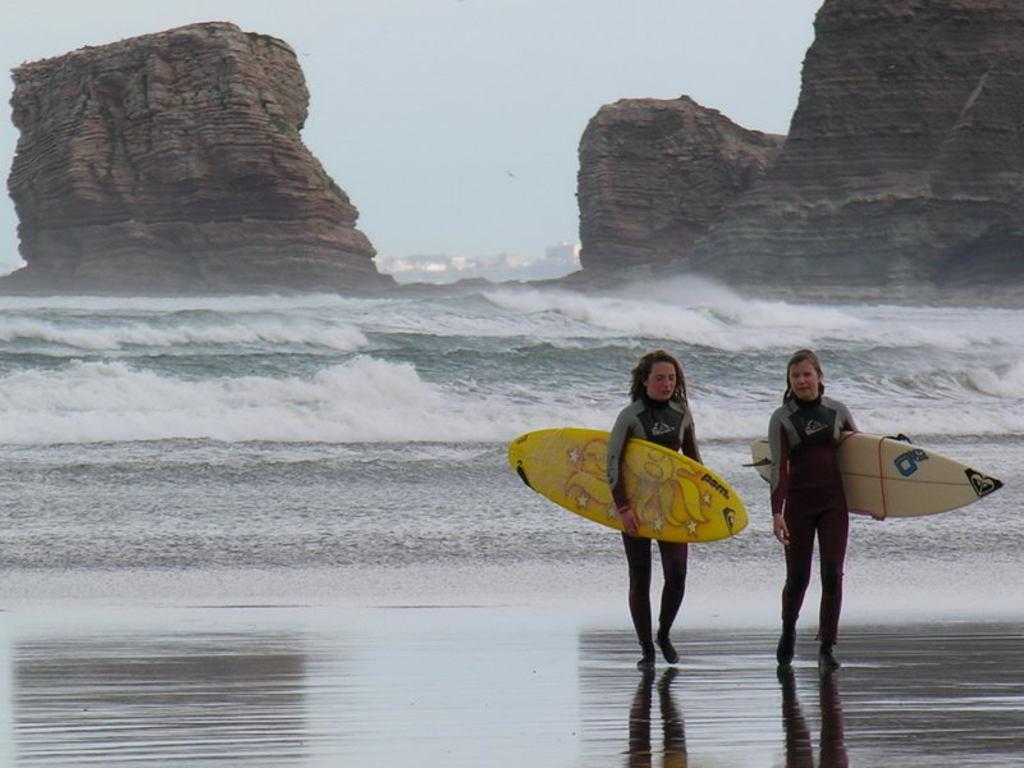Please provide a concise description of this image. As we can see in the image there is a sky, water and two people walking and holding yellow color surfboards. 